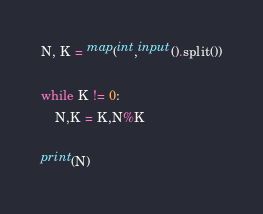Convert code to text. <code><loc_0><loc_0><loc_500><loc_500><_Python_>N, K = map(int,input().split())

while K != 0:
    N,K = K,N%K

print(N)</code> 